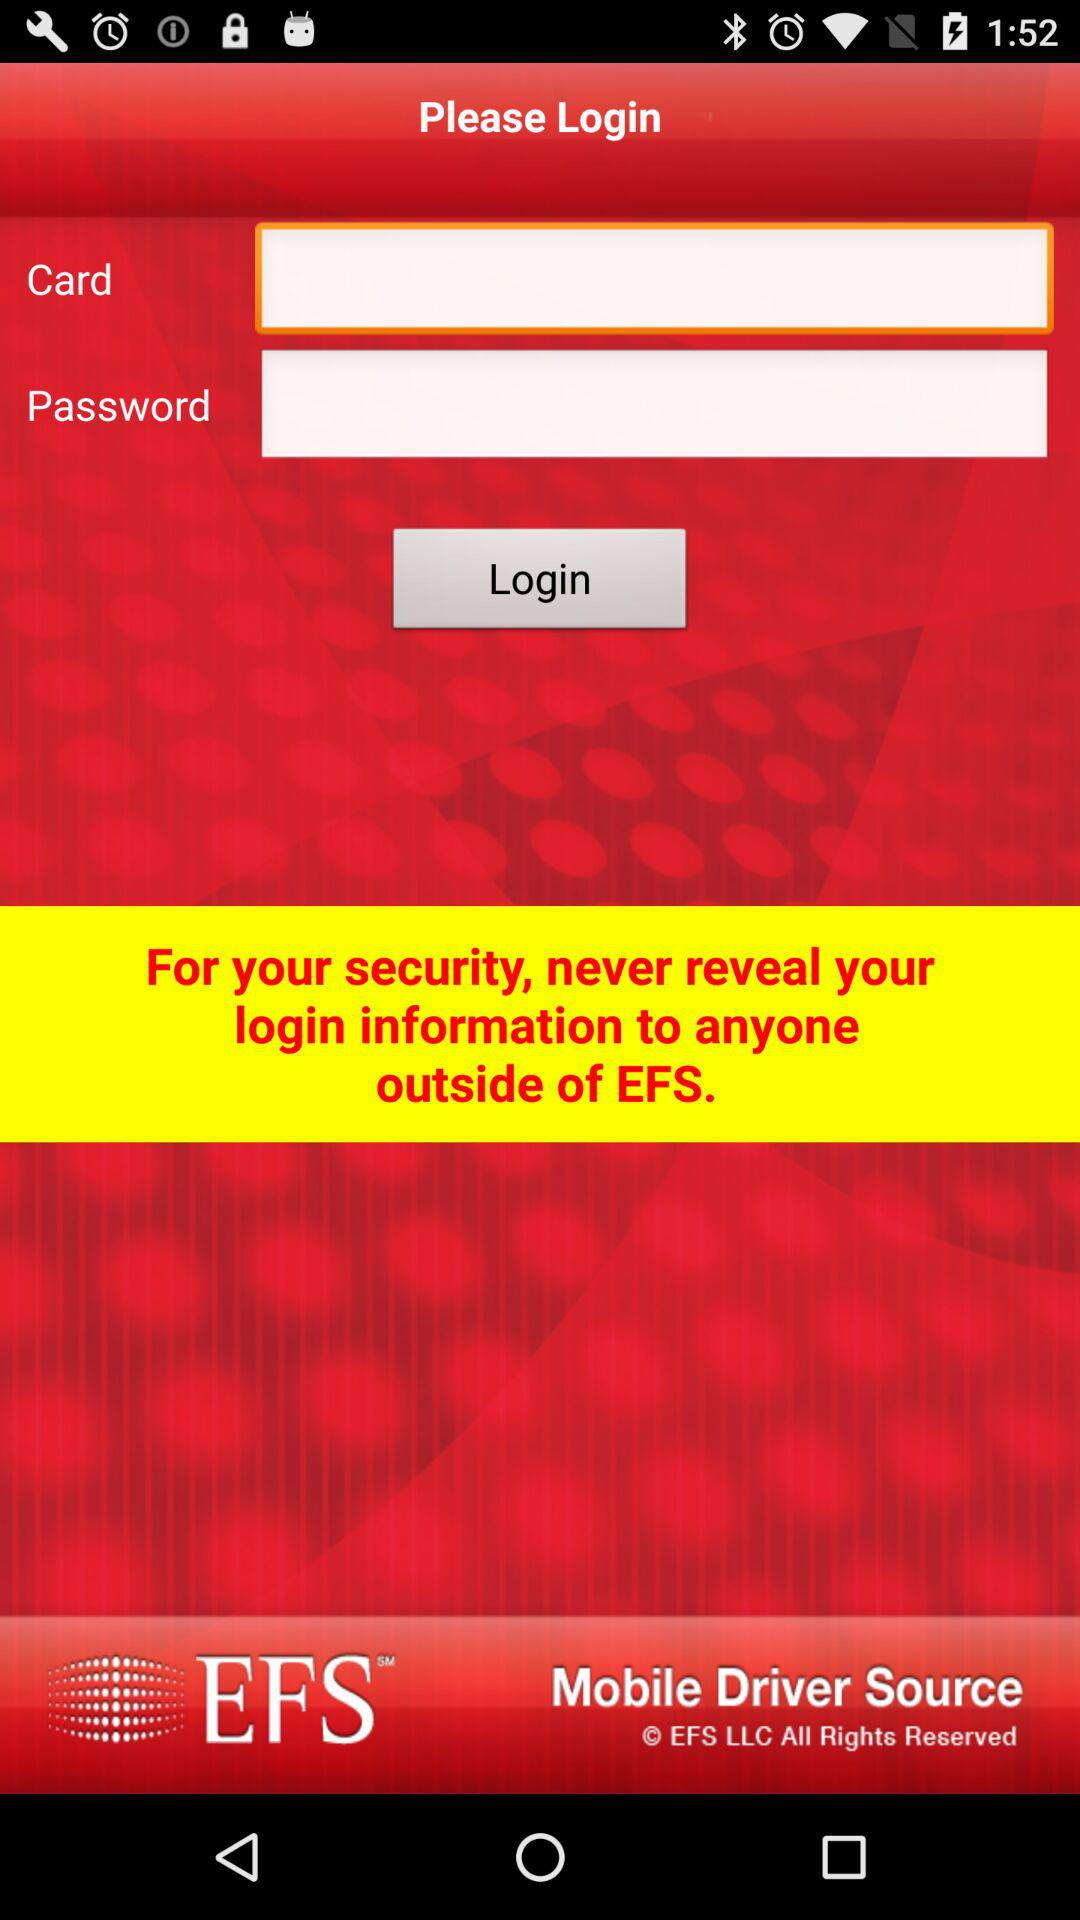What is the name of the application? The application name is "EFS". 